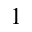<formula> <loc_0><loc_0><loc_500><loc_500>^ { 1 }</formula> 